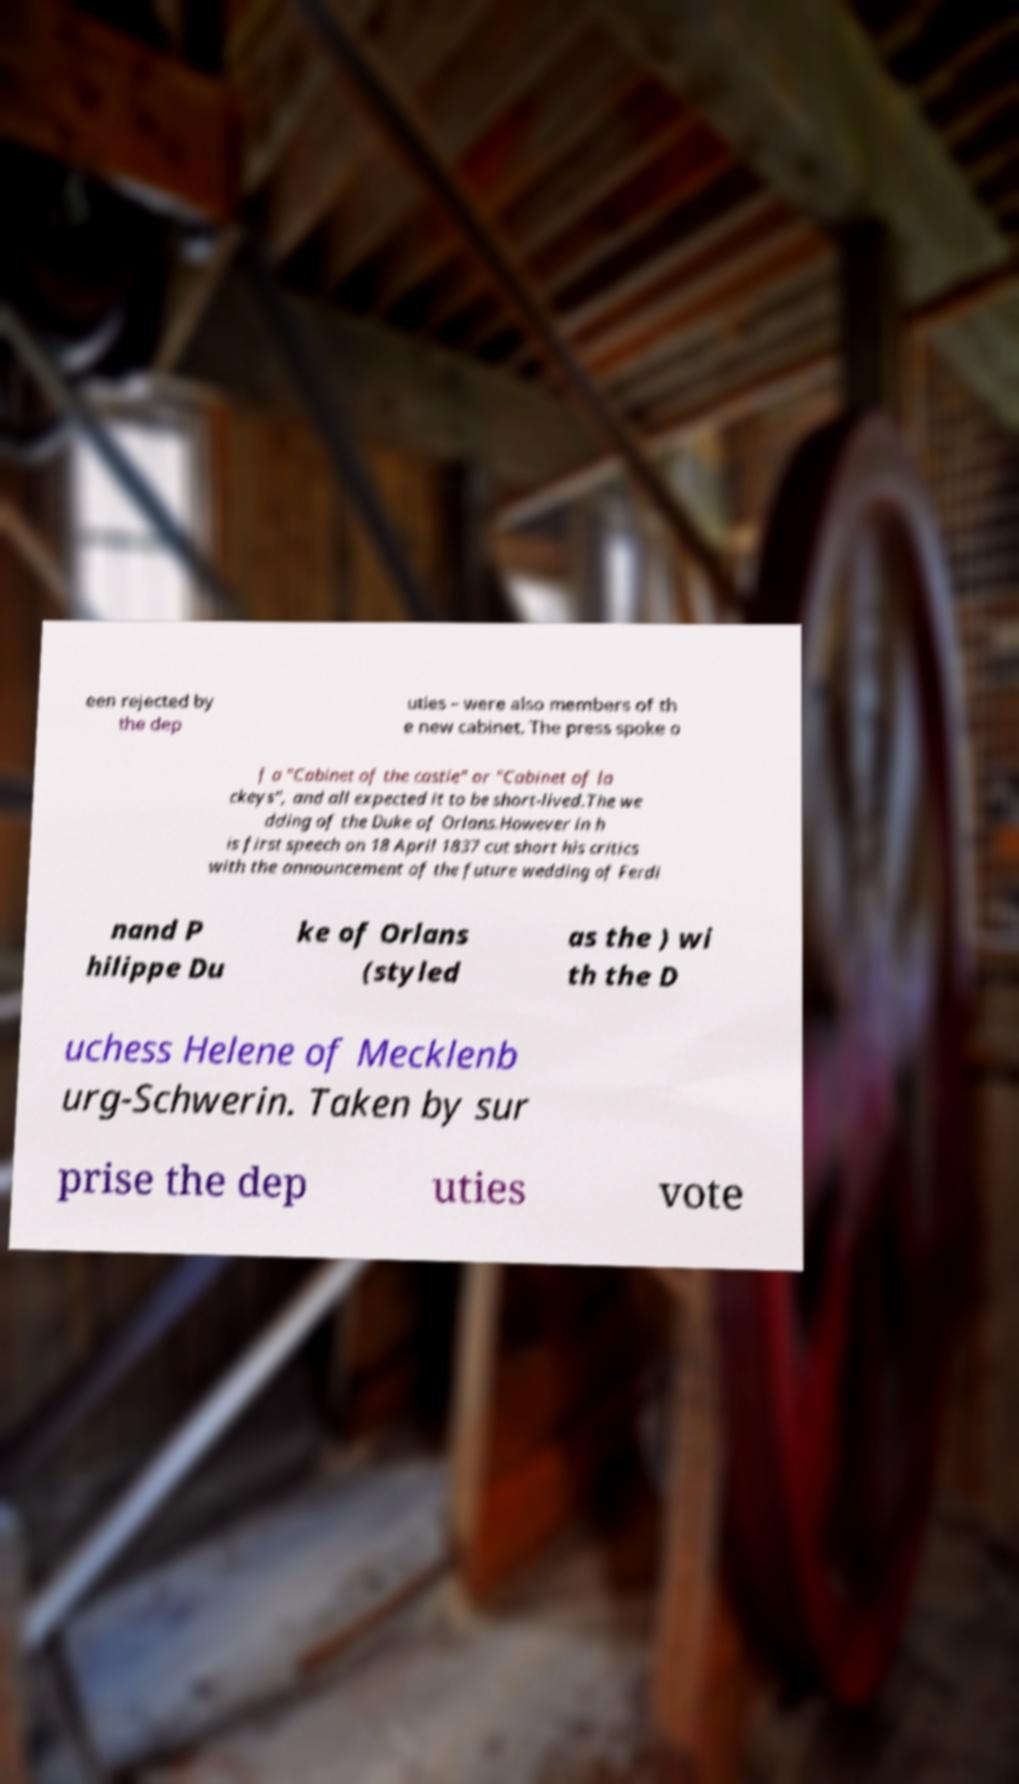Could you extract and type out the text from this image? een rejected by the dep uties – were also members of th e new cabinet. The press spoke o f a "Cabinet of the castle" or "Cabinet of la ckeys", and all expected it to be short-lived.The we dding of the Duke of Orlans.However in h is first speech on 18 April 1837 cut short his critics with the announcement of the future wedding of Ferdi nand P hilippe Du ke of Orlans (styled as the ) wi th the D uchess Helene of Mecklenb urg-Schwerin. Taken by sur prise the dep uties vote 